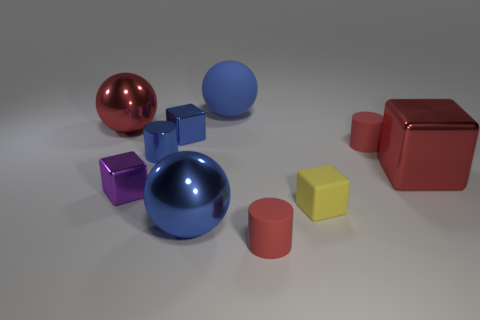Subtract all red metallic spheres. How many spheres are left? 2 Subtract all red balls. How many red cylinders are left? 2 Subtract all blocks. How many objects are left? 6 Add 2 large red metal blocks. How many large red metal blocks exist? 3 Subtract all blue cylinders. How many cylinders are left? 2 Subtract 0 brown cubes. How many objects are left? 10 Subtract all red cylinders. Subtract all red cubes. How many cylinders are left? 1 Subtract all large red blocks. Subtract all purple cubes. How many objects are left? 8 Add 1 tiny matte blocks. How many tiny matte blocks are left? 2 